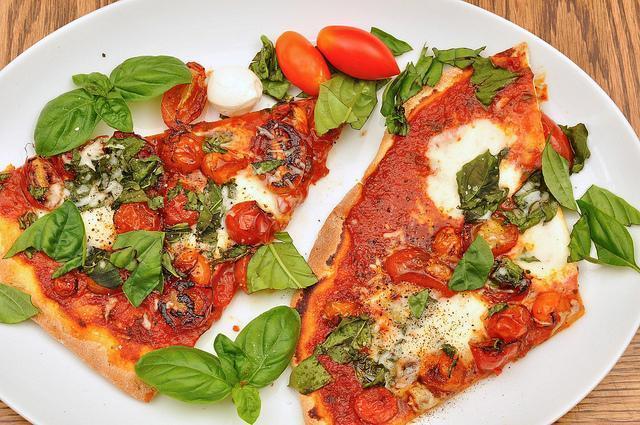How many slices are there?
Give a very brief answer. 2. How many pizzas are in the photo?
Give a very brief answer. 2. How many dining tables are there?
Give a very brief answer. 2. 